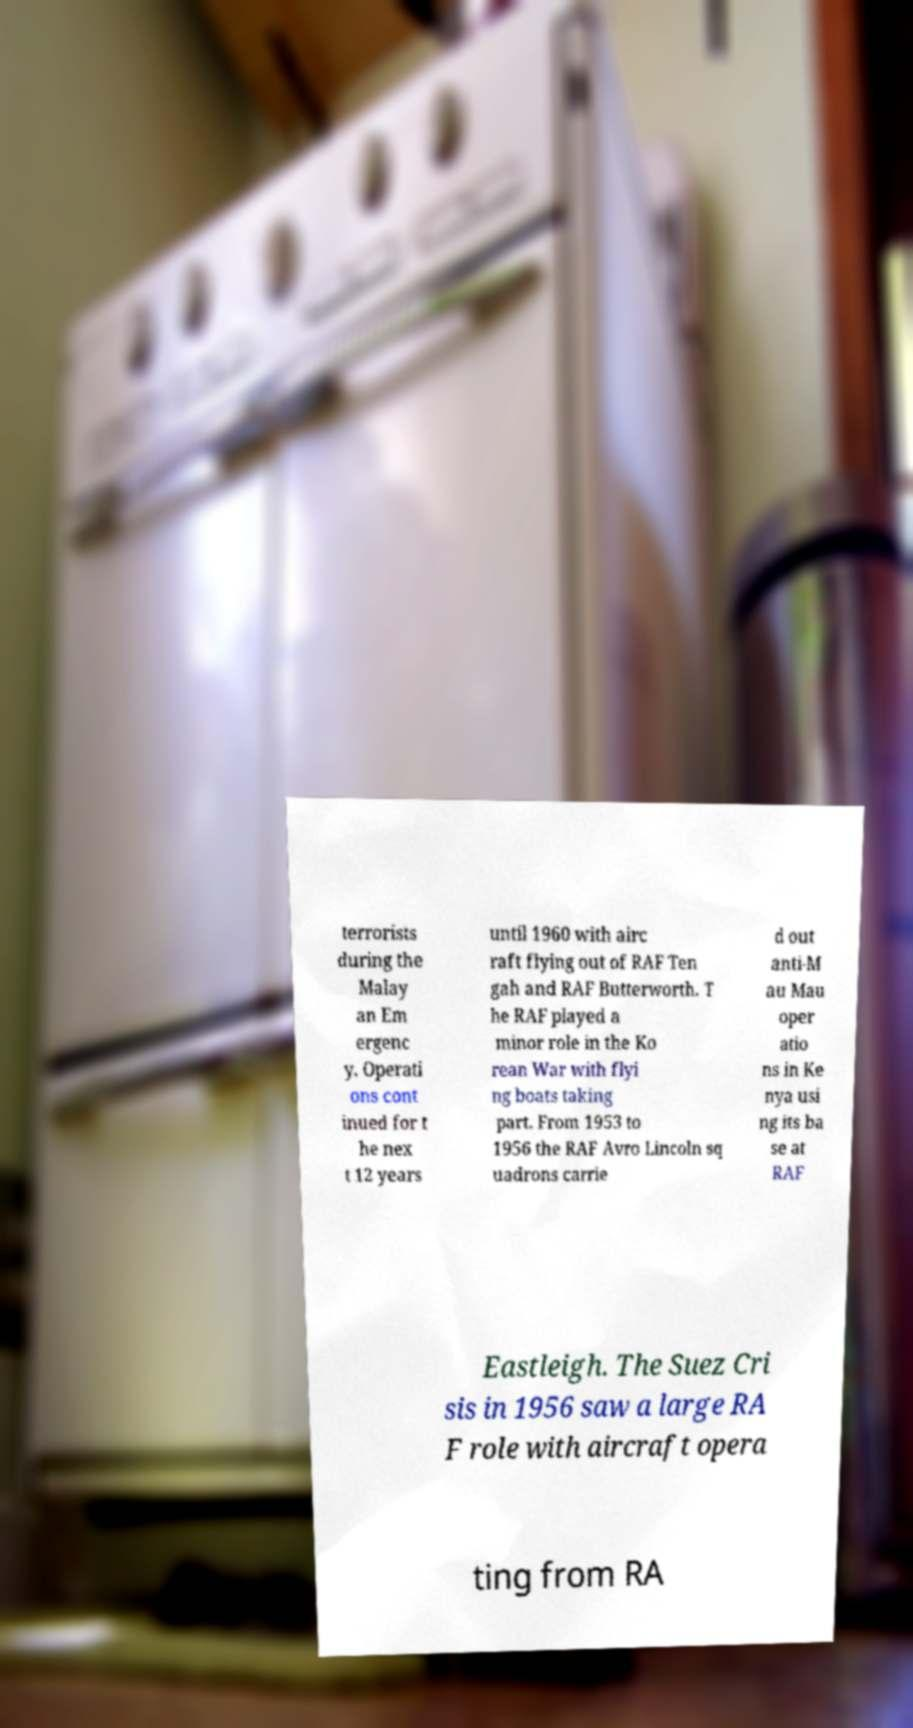Could you extract and type out the text from this image? terrorists during the Malay an Em ergenc y. Operati ons cont inued for t he nex t 12 years until 1960 with airc raft flying out of RAF Ten gah and RAF Butterworth. T he RAF played a minor role in the Ko rean War with flyi ng boats taking part. From 1953 to 1956 the RAF Avro Lincoln sq uadrons carrie d out anti-M au Mau oper atio ns in Ke nya usi ng its ba se at RAF Eastleigh. The Suez Cri sis in 1956 saw a large RA F role with aircraft opera ting from RA 